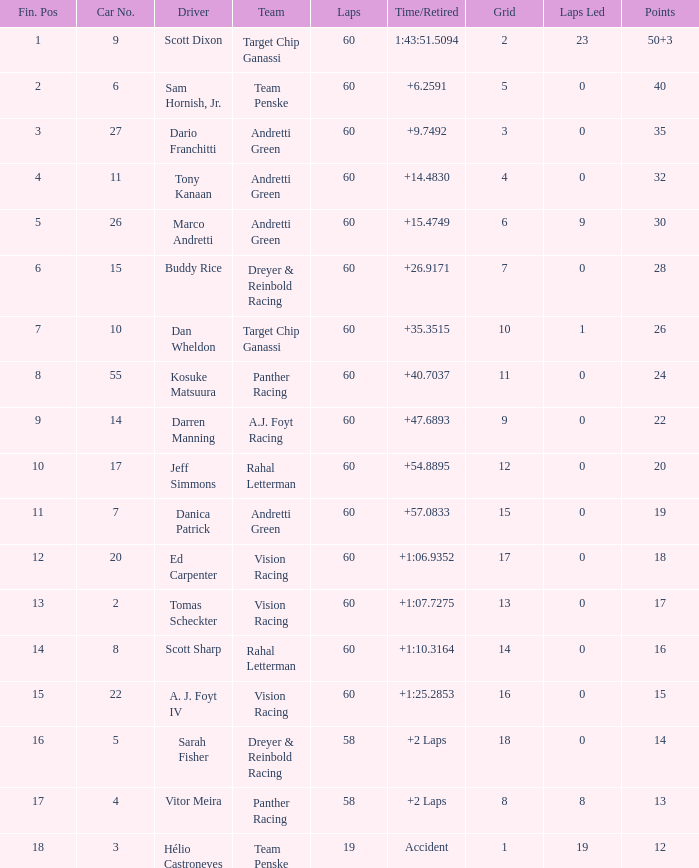Identify the team that darren manning is a part of. A.J. Foyt Racing. 